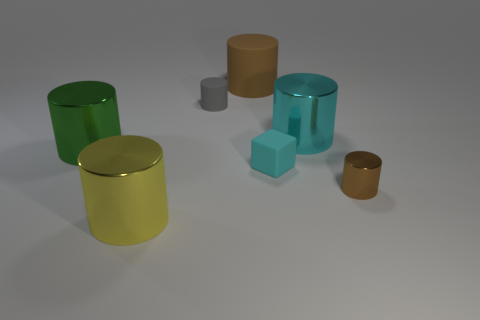Subtract all matte cylinders. How many cylinders are left? 4 Subtract 2 cylinders. How many cylinders are left? 4 Add 1 small gray things. How many objects exist? 8 Subtract all brown cylinders. How many cylinders are left? 4 Subtract all green cylinders. Subtract all brown blocks. How many cylinders are left? 5 Subtract all cylinders. How many objects are left? 1 Add 1 blocks. How many blocks are left? 2 Add 3 big brown things. How many big brown things exist? 4 Subtract 0 red cylinders. How many objects are left? 7 Subtract all tiny matte cylinders. Subtract all tiny spheres. How many objects are left? 6 